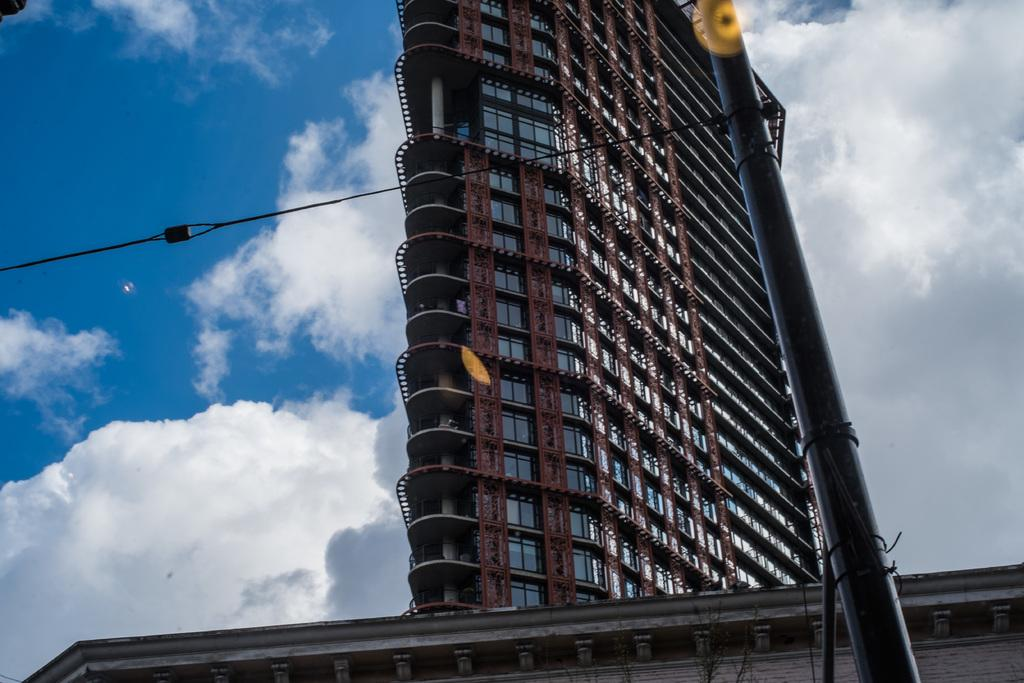What type of building is shown in the image? There is a big building with glass walls in the image. What can be seen at the top of the image? The sky is visible at the top of the image. How would you describe the sky in the image? The sky appears to be cloudy. What type of square is present in the image? There is no square present in the image; it features a big building with glass walls and a cloudy sky. 